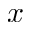Convert formula to latex. <formula><loc_0><loc_0><loc_500><loc_500>x</formula> 